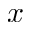Convert formula to latex. <formula><loc_0><loc_0><loc_500><loc_500>x</formula> 